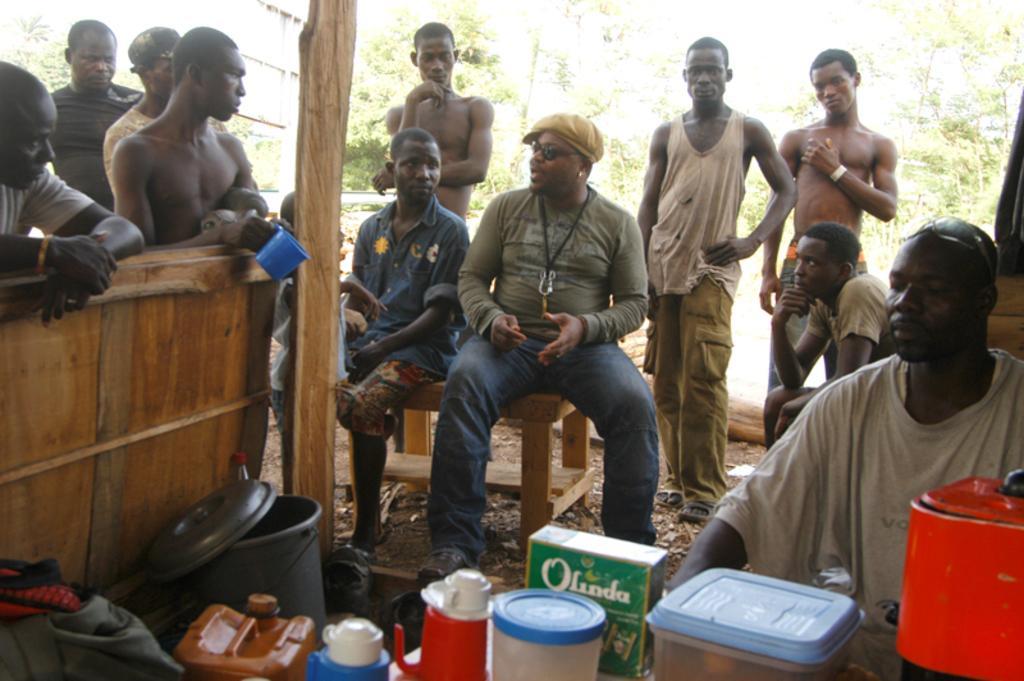Please provide a concise description of this image. There are many people. Some are sitting and some are standing. There is a wooden pole. Also there is a bucket, bottles, packet, box and many other items. In the background there are trees. Also there is a person wearing cap, goggles and something on the neck. 